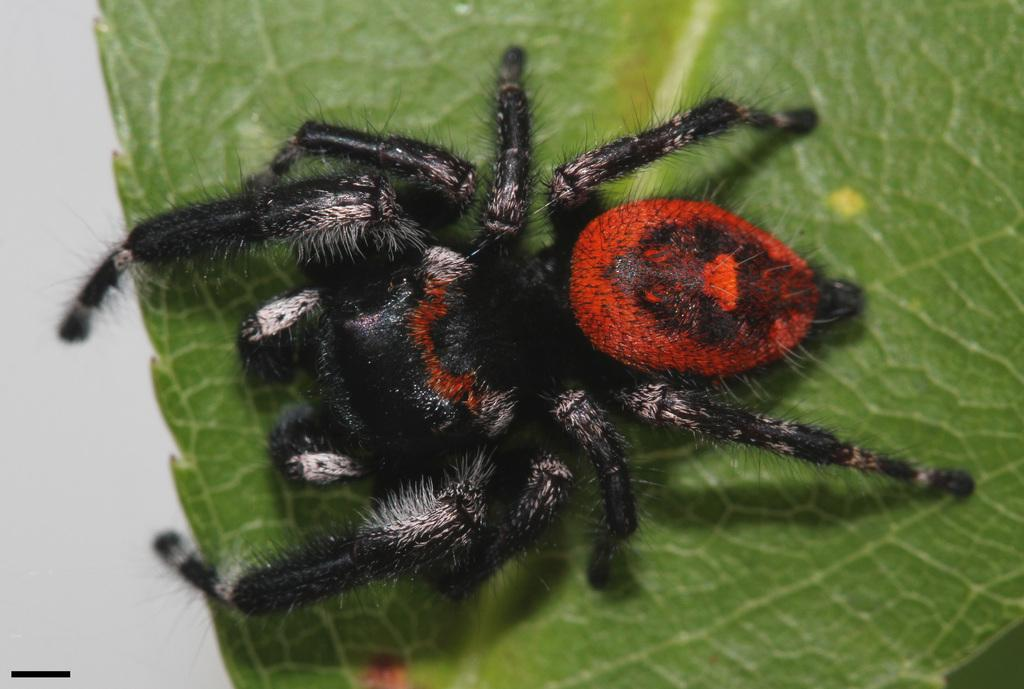What is the main subject of the picture? The main subject of the picture is a spider. Can you describe the appearance of the spider? The spider is black and red in color. Where is the spider located in the picture? The spider is on a leaf. What type of verse can be heard being recited by the spider in the image? There is no indication in the image that the spider is reciting a verse, so it cannot be determined from the picture. 